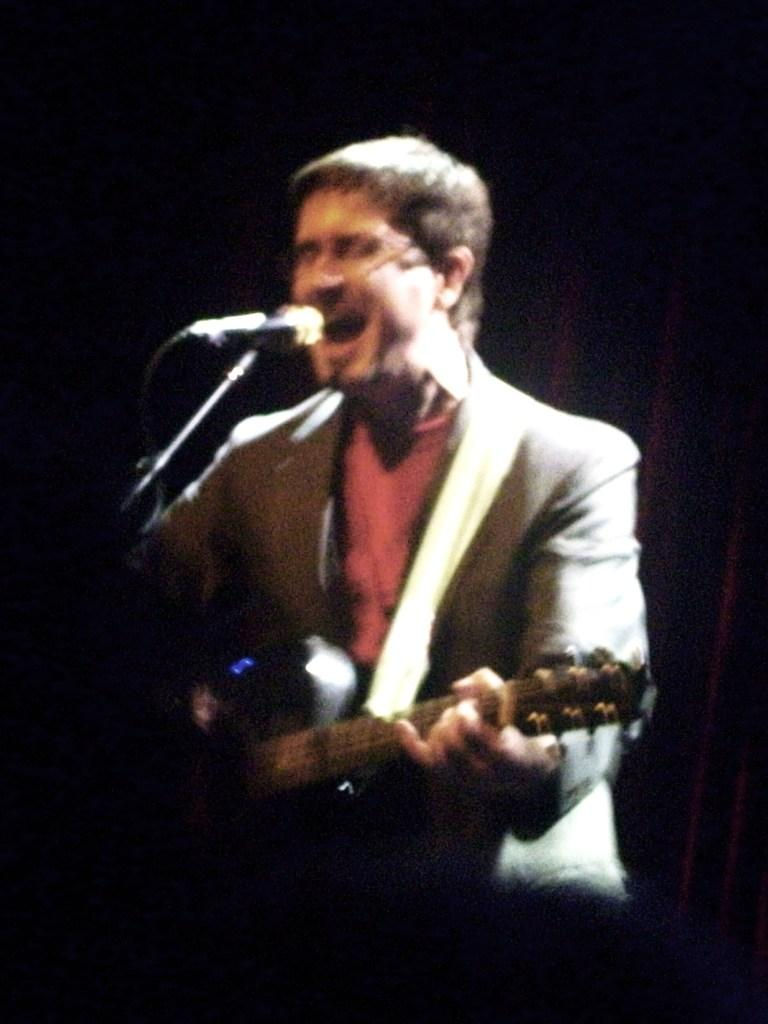What is the person in the image doing? The person is singing and playing a guitar. How is the person playing the guitar? The guitar is in the person's hand. What is the person using to amplify their voice? There is a microphone (mic) in front of the person. Can you see a zebra playing the guitar in the image? No, there is no zebra present in the image. What type of box is being used to store the guitar? There is no box mentioned or visible in the image. 